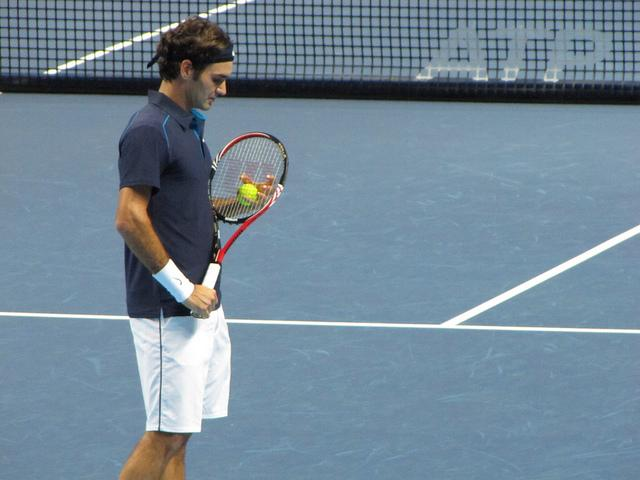What hair accessory is the player wearing to keep his hair out of his face? headband 